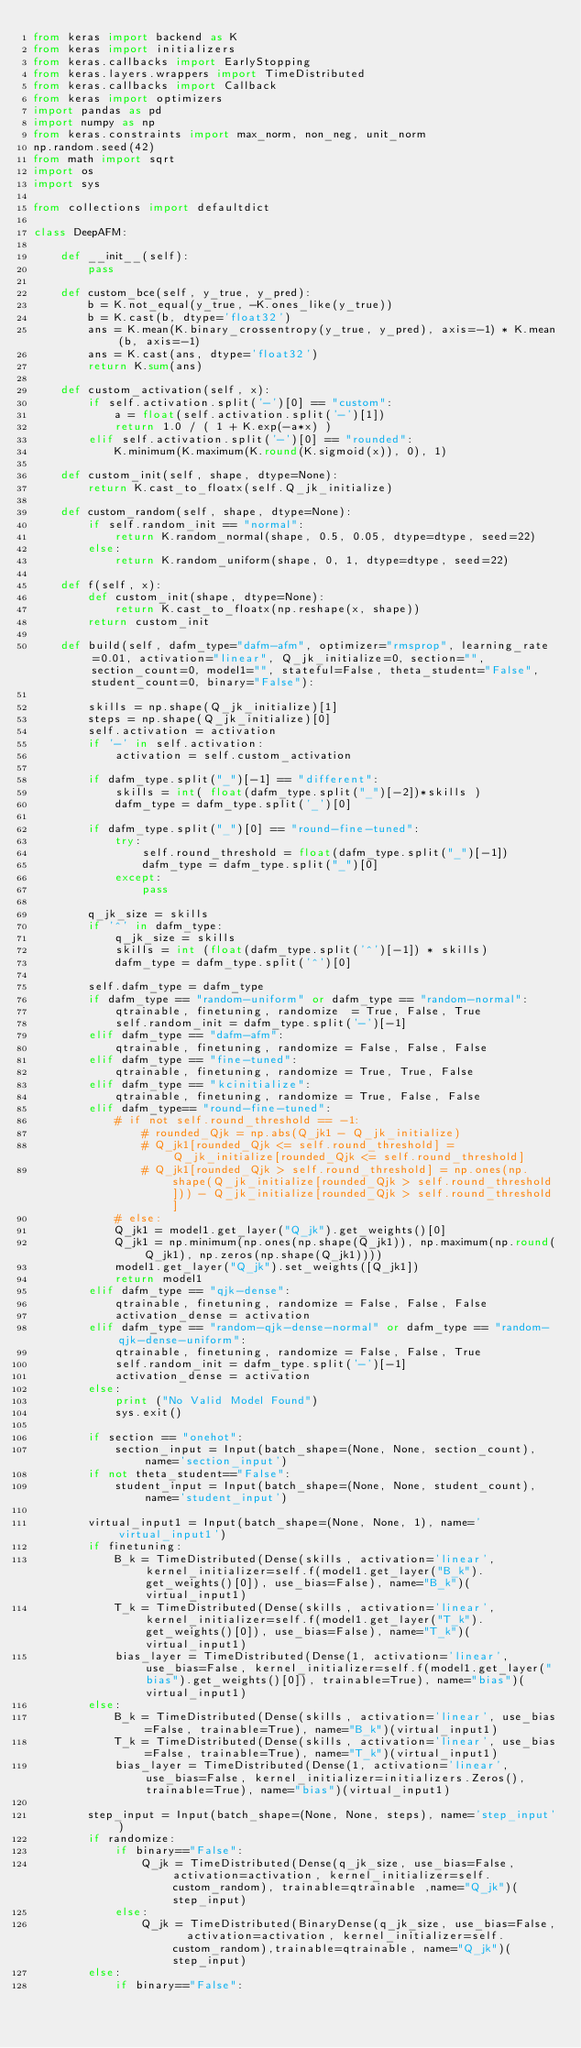Convert code to text. <code><loc_0><loc_0><loc_500><loc_500><_Python_>from keras import backend as K
from keras import initializers
from keras.callbacks import EarlyStopping
from keras.layers.wrappers import TimeDistributed
from keras.callbacks import Callback
from keras import optimizers
import pandas as pd
import numpy as np
from keras.constraints import max_norm, non_neg, unit_norm
np.random.seed(42)
from math import sqrt
import os
import sys

from collections import defaultdict

class DeepAFM:

    def __init__(self):
        pass

    def custom_bce(self, y_true, y_pred):
        b = K.not_equal(y_true, -K.ones_like(y_true))
        b = K.cast(b, dtype='float32')
        ans = K.mean(K.binary_crossentropy(y_true, y_pred), axis=-1) * K.mean(b, axis=-1)
        ans = K.cast(ans, dtype='float32')
        return K.sum(ans)

    def custom_activation(self, x):
        if self.activation.split('-')[0] == "custom":
            a = float(self.activation.split('-')[1])
            return 1.0 / ( 1 + K.exp(-a*x) )
        elif self.activation.split('-')[0] == "rounded":
            K.minimum(K.maximum(K.round(K.sigmoid(x)), 0), 1)

    def custom_init(self, shape, dtype=None):
        return K.cast_to_floatx(self.Q_jk_initialize)

    def custom_random(self, shape, dtype=None):
        if self.random_init == "normal":
            return K.random_normal(shape, 0.5, 0.05, dtype=dtype, seed=22)
        else:
            return K.random_uniform(shape, 0, 1, dtype=dtype, seed=22)

    def f(self, x):
        def custom_init(shape, dtype=None):
            return K.cast_to_floatx(np.reshape(x, shape))
        return custom_init

    def build(self, dafm_type="dafm-afm", optimizer="rmsprop", learning_rate=0.01, activation="linear", Q_jk_initialize=0, section="", section_count=0, model1="", stateful=False, theta_student="False", student_count=0, binary="False"):

        skills = np.shape(Q_jk_initialize)[1]
        steps = np.shape(Q_jk_initialize)[0]
        self.activation = activation
        if '-' in self.activation:
            activation = self.custom_activation

        if dafm_type.split("_")[-1] == "different":
            skills = int( float(dafm_type.split("_")[-2])*skills )
            dafm_type = dafm_type.split('_')[0]

        if dafm_type.split("_")[0] == "round-fine-tuned":
            try:
                self.round_threshold = float(dafm_type.split("_")[-1])
                dafm_type = dafm_type.split("_")[0]
            except:
                pass

        q_jk_size = skills
        if '^' in dafm_type:
            q_jk_size = skills
            skills = int (float(dafm_type.split('^')[-1]) * skills)
            dafm_type = dafm_type.split('^')[0]

        self.dafm_type = dafm_type
        if dafm_type == "random-uniform" or dafm_type == "random-normal":
            qtrainable, finetuning, randomize  = True, False, True
            self.random_init = dafm_type.split('-')[-1]
        elif dafm_type == "dafm-afm":
            qtrainable, finetuning, randomize = False, False, False
        elif dafm_type == "fine-tuned":
            qtrainable, finetuning, randomize = True, True, False
        elif dafm_type == "kcinitialize":
            qtrainable, finetuning, randomize = True, False, False
        elif dafm_type== "round-fine-tuned":
            # if not self.round_threshold == -1:
                # rounded_Qjk = np.abs(Q_jk1 - Q_jk_initialize)
                # Q_jk1[rounded_Qjk <= self.round_threshold] = Q_jk_initialize[rounded_Qjk <= self.round_threshold]
                # Q_jk1[rounded_Qjk > self.round_threshold] = np.ones(np.shape(Q_jk_initialize[rounded_Qjk > self.round_threshold])) - Q_jk_initialize[rounded_Qjk > self.round_threshold]
            # else:
            Q_jk1 = model1.get_layer("Q_jk").get_weights()[0]
            Q_jk1 = np.minimum(np.ones(np.shape(Q_jk1)), np.maximum(np.round(Q_jk1), np.zeros(np.shape(Q_jk1))))
            model1.get_layer("Q_jk").set_weights([Q_jk1])
            return model1
        elif dafm_type == "qjk-dense":
            qtrainable, finetuning, randomize = False, False, False
            activation_dense = activation
        elif dafm_type == "random-qjk-dense-normal" or dafm_type == "random-qjk-dense-uniform":
            qtrainable, finetuning, randomize = False, False, True
            self.random_init = dafm_type.split('-')[-1]
            activation_dense = activation
        else:
            print ("No Valid Model Found")
            sys.exit()

        if section == "onehot":
            section_input = Input(batch_shape=(None, None, section_count), name='section_input')
        if not theta_student=="False":
            student_input = Input(batch_shape=(None, None, student_count), name='student_input')

        virtual_input1 = Input(batch_shape=(None, None, 1), name='virtual_input1')
        if finetuning:
            B_k = TimeDistributed(Dense(skills, activation='linear', kernel_initializer=self.f(model1.get_layer("B_k").get_weights()[0]), use_bias=False), name="B_k")(virtual_input1)
            T_k = TimeDistributed(Dense(skills, activation='linear', kernel_initializer=self.f(model1.get_layer("T_k").get_weights()[0]), use_bias=False), name="T_k")(virtual_input1)
            bias_layer = TimeDistributed(Dense(1, activation='linear', use_bias=False, kernel_initializer=self.f(model1.get_layer("bias").get_weights()[0]), trainable=True), name="bias")(virtual_input1)
        else:
            B_k = TimeDistributed(Dense(skills, activation='linear', use_bias=False, trainable=True), name="B_k")(virtual_input1)
            T_k = TimeDistributed(Dense(skills, activation='linear', use_bias=False, trainable=True), name="T_k")(virtual_input1)
            bias_layer = TimeDistributed(Dense(1, activation='linear', use_bias=False, kernel_initializer=initializers.Zeros(), trainable=True), name="bias")(virtual_input1)

        step_input = Input(batch_shape=(None, None, steps), name='step_input')
        if randomize:
            if binary=="False":
                Q_jk = TimeDistributed(Dense(q_jk_size, use_bias=False, activation=activation, kernel_initializer=self.custom_random), trainable=qtrainable ,name="Q_jk")(step_input)
            else:
                Q_jk = TimeDistributed(BinaryDense(q_jk_size, use_bias=False,  activation=activation, kernel_initializer=self.custom_random),trainable=qtrainable, name="Q_jk")(step_input)
        else:
            if binary=="False":</code> 